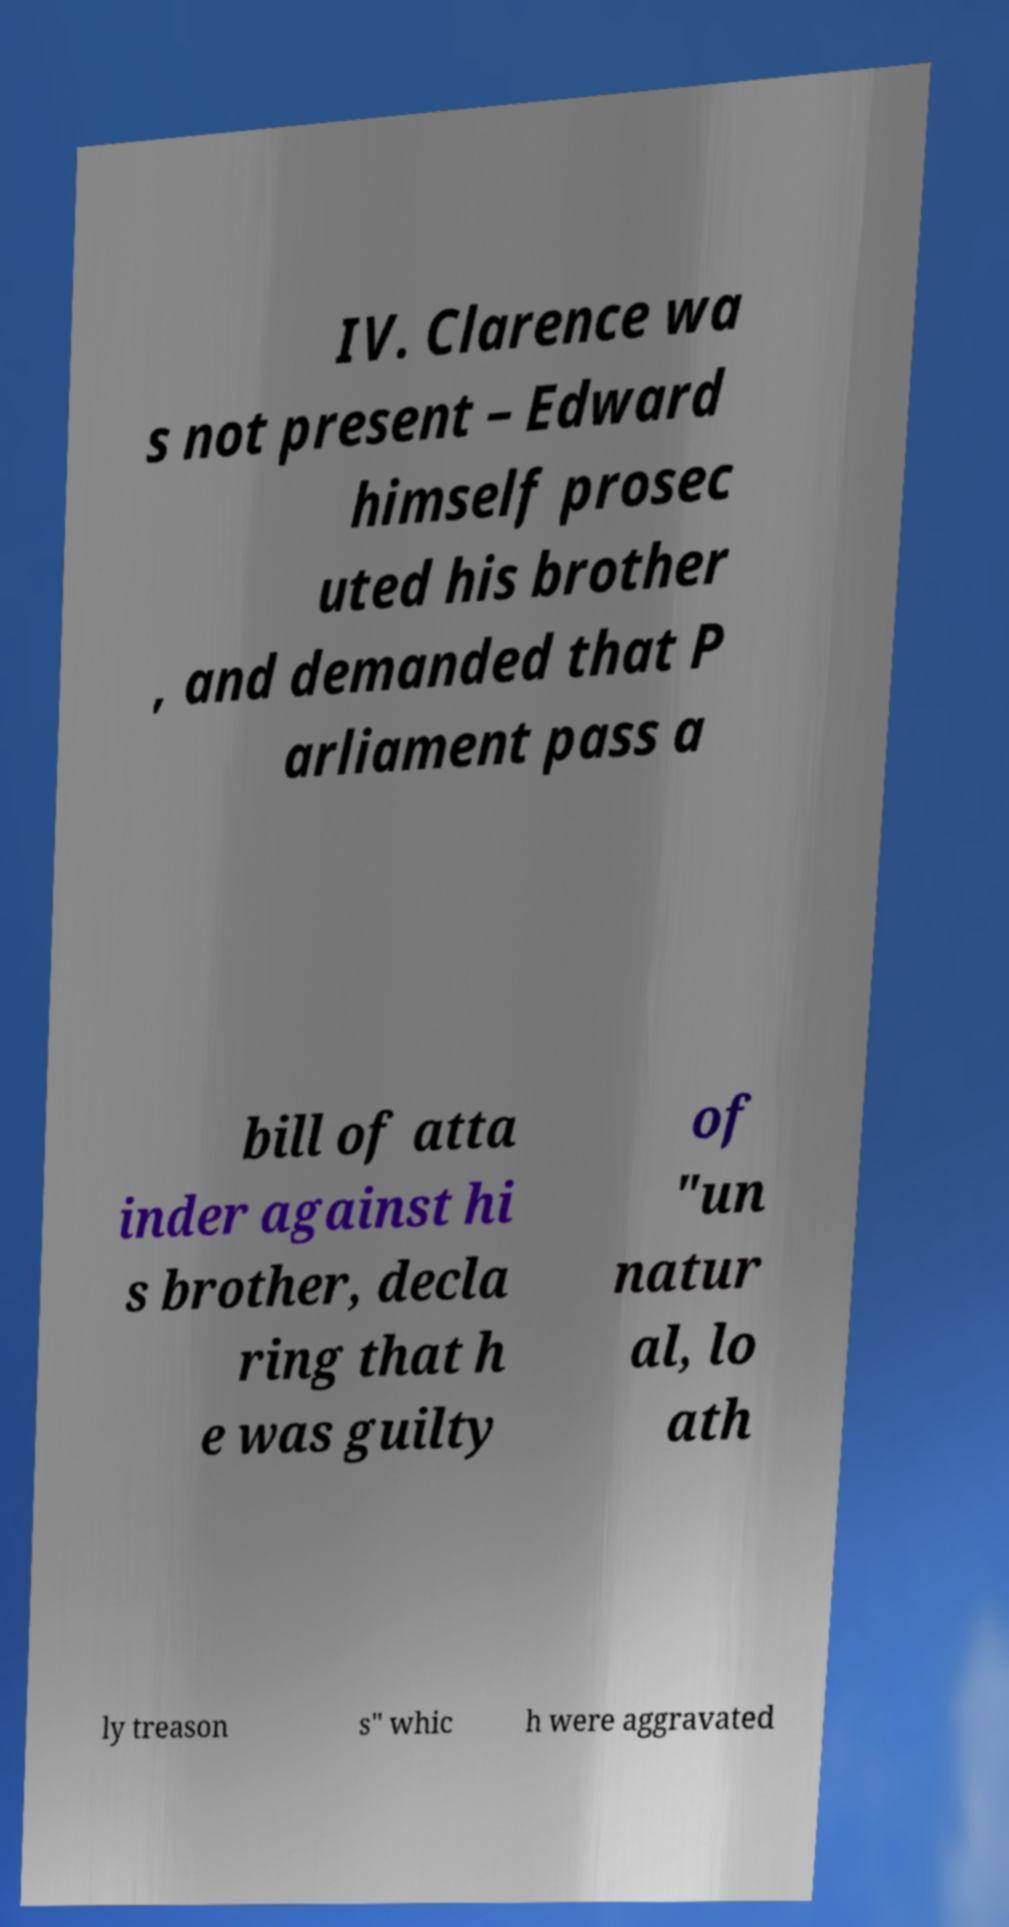There's text embedded in this image that I need extracted. Can you transcribe it verbatim? IV. Clarence wa s not present – Edward himself prosec uted his brother , and demanded that P arliament pass a bill of atta inder against hi s brother, decla ring that h e was guilty of "un natur al, lo ath ly treason s" whic h were aggravated 